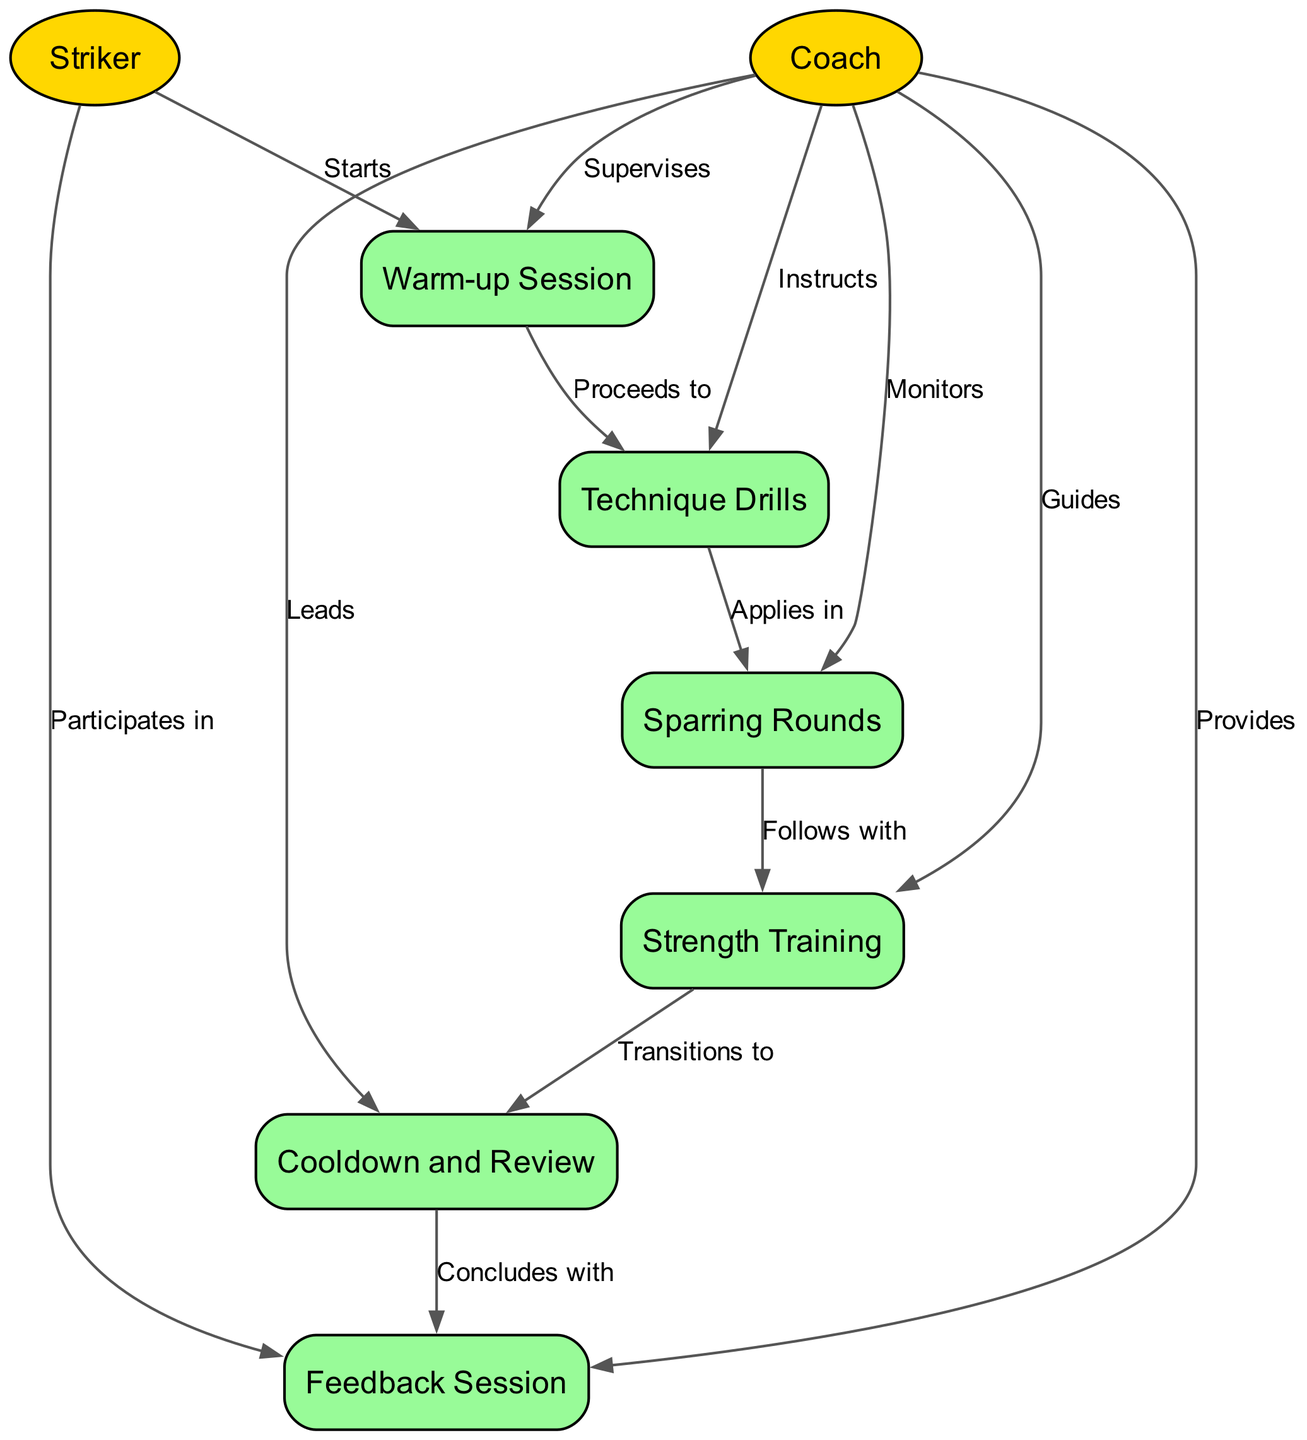What is the first activity in the training session? The diagram indicates that the first activity in the training session is the "Warm-up Session," which is initiated by the Striker and supervised by the Coach.
Answer: Warm-up Session How many activities are represented in the diagram? By counting the nodes categorized as activities, there are six activities in total: Warm-up Session, Technique Drills, Sparring Rounds, Strength Training, Cooldown and Review, and Feedback Session.
Answer: Six What do the Striker and Coach do during the Cooldown and Review? According to the diagram, during the Cooldown and Review, the Coach leads the session while the Striker participates. This indicates a collaborative evaluation and relaxation stage following intense training.
Answer: Leads and participates Which activity follows the Sparring Rounds? The diagram shows a direct continuation from Sparring Rounds to Strength Training, indicating that it's the subsequent activity once sparring is completed.
Answer: Strength Training Who instructs during the Technique Drills? The relationship in the diagram reveals that the Coach is the one giving instructions during the Technique Drills, guiding the Striker through the technique learning process.
Answer: Coach How many actors are involved in the training session workflow? There are two actors in this diagram: the Striker and the Coach. The diagram highlights both roles within the training session workflow.
Answer: Two What activity concludes the training session? The diagram indicates that the last activity before wrapping up the training session is the Feedback Session, signifying a final review discussion.
Answer: Feedback Session What is the relationship between the Coach and the Sparring Rounds? The diagram describes the Coach as monitoring the Sparring Rounds, which indicates a supervisory relationship during this practice phase.
Answer: Monitors What follows after the Strength Training activity? The sequence flows from Strength Training directly to Cooldown and Review, indicating that it is the next step in the training process.
Answer: Cooldown and Review 